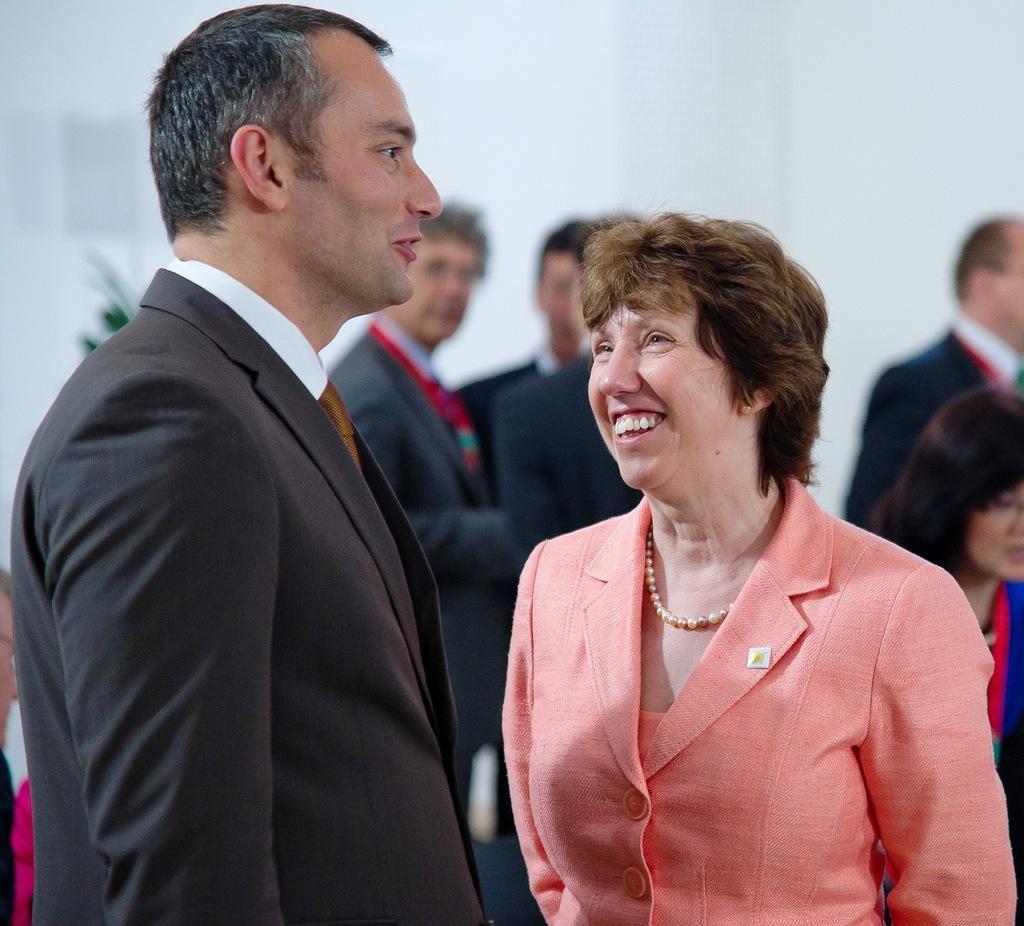In one or two sentences, can you explain what this image depicts? In this picture we can see a man and a woman standing and smiling in the front, in the background there are some people standing, this man wore a suit. 